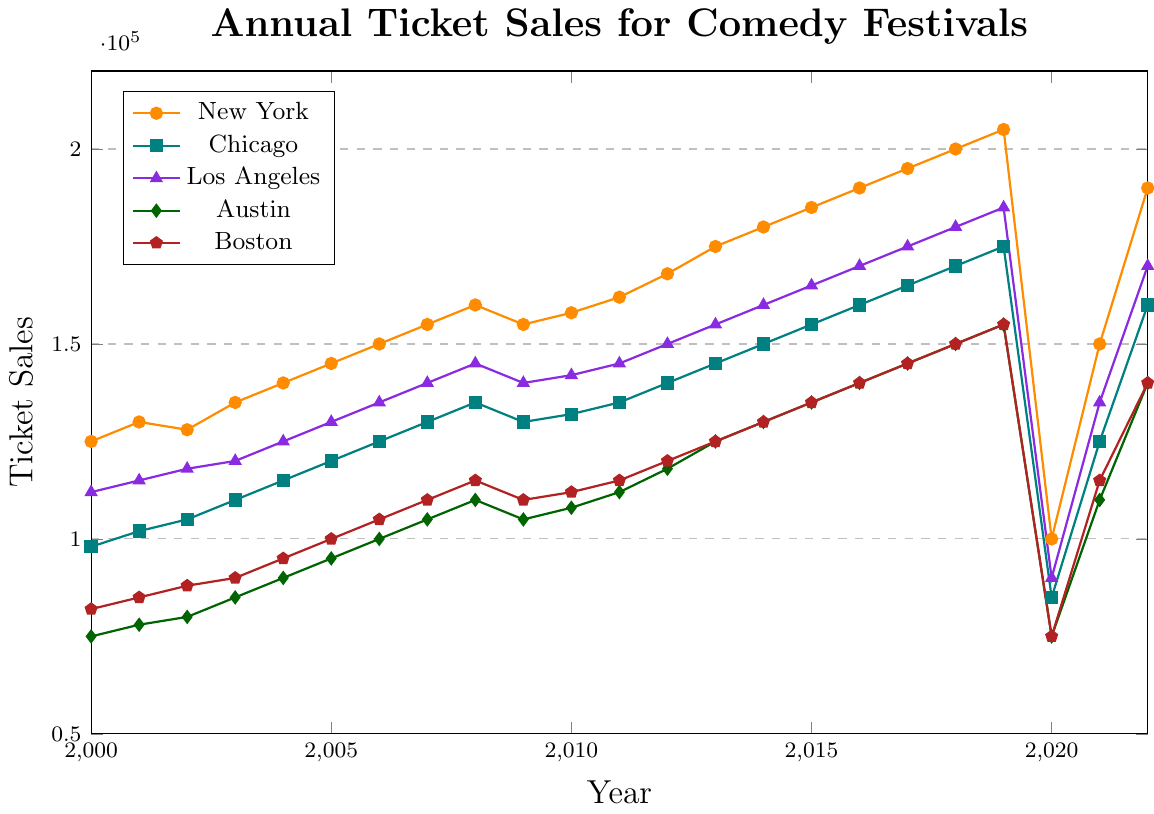What's the highest ticket sales value for New York before 2020? To determine this, we need to scan the New York ticket sales data from 2000 to 2019. The highest value is 205,000 in 2019.
Answer: 205,000 How much did ticket sales in Austin increase from 2000 to 2019? Starting in 2000, the sales in Austin were 75,000. By 2019, they had reached 155,000. The increase is 155,000 - 75,000 = 80,000.
Answer: 80,000 Which city had the most significant drop in ticket sales in 2020 compared to 2019? Comparing the sales in 2019 and 2020 for each city, New York dropped from 205,000 to 100,000, a decrease of 105,000, which is the largest among the cities.
Answer: New York What was the trend of ticket sales for Boston from 2000 to 2022? Examining the Boston data from 2000 to 2022, we see an overall increasing trend, peaking at 155,000 in 2019, with a drop in 2020, followed by a recovery.
Answer: Increasing with a drop in 2020 Which city had a higher ticket sales recovery from 2020 to 2021, Chicago or Los Angeles? In Chicago, sales went from 85,000 in 2020 to 125,000 in 2021, an increase of 40,000. In Los Angeles, sales went from 90,000 in 2020 to 135,000 in 2021, an increase of 45,000. Thus, Los Angeles had a higher recovery.
Answer: Los Angeles What was the average yearly ticket sales for Los Angeles between 2010 and 2019? Summing the Los Angeles sales from 2010 to 2019 and dividing by 10: (142,000 + 145,000 + 150,000 + 155,000 + 160,000 + 165,000 + 170,000 + 175,000 + 180,000 + 185,000) = 1,529,000 / 10 = 152,900.
Answer: 152,900 Which city showed a consistent increase in ticket sales from 2000 to 2021 without any drop? Reviewing the data, none. All cities show at least one drop at some point in the given timeline.
Answer: None In which year did Austin ticket sales first reach 100,000? Austin's ticket sales reached 100,000 in the year 2006.
Answer: 2006 How do ticket sales for Los Angeles in 2020 compare to Chicago in the same year? Los Angeles had 90,000 sales in 2020, while Chicago had 85,000. Los Angeles had higher ticket sales than Chicago in 2020.
Answer: Los Angeles had higher sales Which city had the smallest increase in ticket sales from 2000 to 2022? From 2000 to 2022, New York had an increase from 125,000 to 190,000 (65,000), Chicago from 98,000 to 160,000 (62,000), Los Angeles from 112,000 to 170,000 (58,000), Austin from 75,000 to 140,000 (65,000), and Boston from 82,000 to 140,000 (58,000). Los Angeles and Boston had the smallest increase of 58,000.
Answer: Los Angeles and Boston 